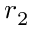Convert formula to latex. <formula><loc_0><loc_0><loc_500><loc_500>r _ { 2 }</formula> 